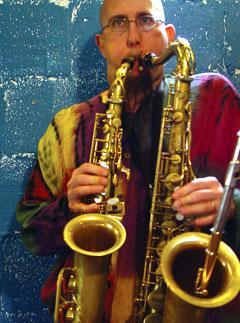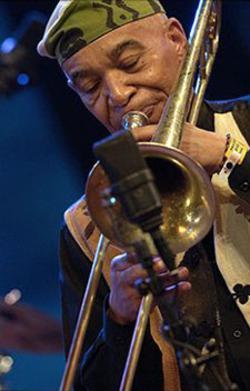The first image is the image on the left, the second image is the image on the right. Analyze the images presented: Is the assertion "Left image shows a man simultaneously playing two brass instruments, and the right image does not." valid? Answer yes or no. Yes. The first image is the image on the left, the second image is the image on the right. Given the left and right images, does the statement "The musician in the image on the left is playing two saxes." hold true? Answer yes or no. Yes. 